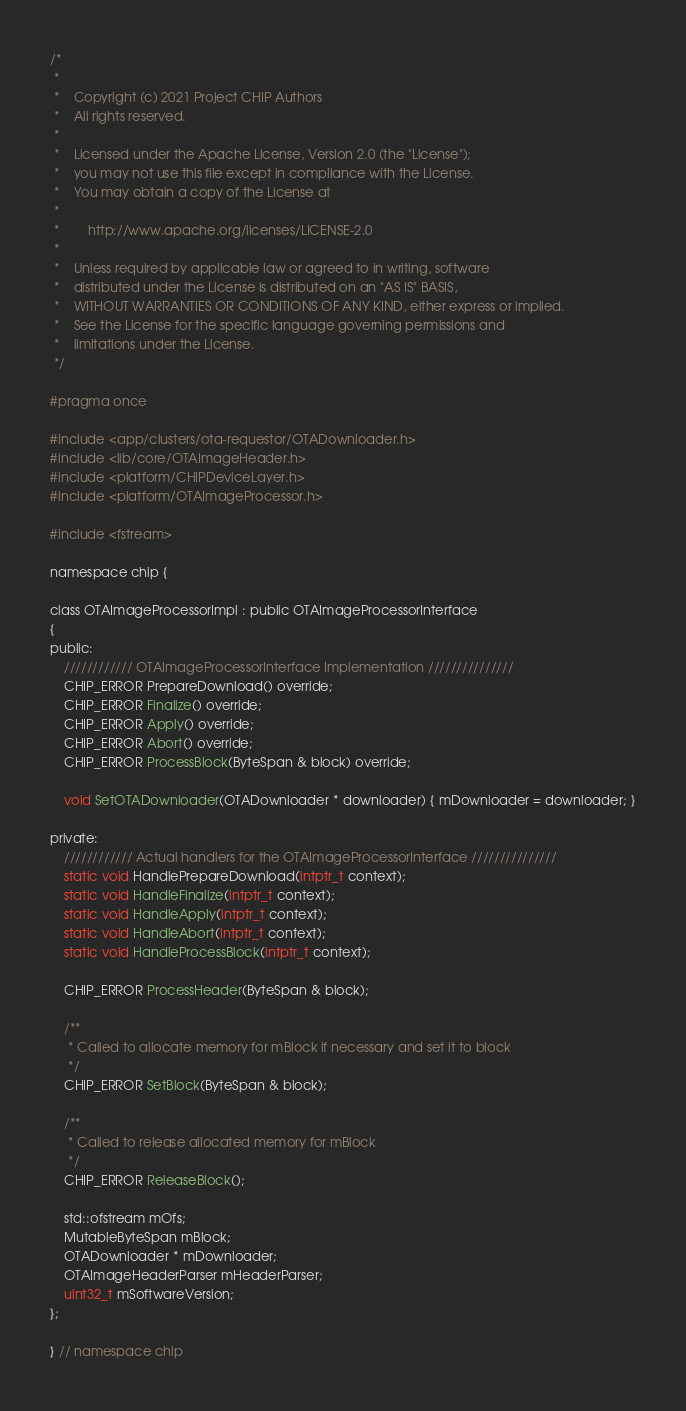<code> <loc_0><loc_0><loc_500><loc_500><_C_>/*
 *
 *    Copyright (c) 2021 Project CHIP Authors
 *    All rights reserved.
 *
 *    Licensed under the Apache License, Version 2.0 (the "License");
 *    you may not use this file except in compliance with the License.
 *    You may obtain a copy of the License at
 *
 *        http://www.apache.org/licenses/LICENSE-2.0
 *
 *    Unless required by applicable law or agreed to in writing, software
 *    distributed under the License is distributed on an "AS IS" BASIS,
 *    WITHOUT WARRANTIES OR CONDITIONS OF ANY KIND, either express or implied.
 *    See the License for the specific language governing permissions and
 *    limitations under the License.
 */

#pragma once

#include <app/clusters/ota-requestor/OTADownloader.h>
#include <lib/core/OTAImageHeader.h>
#include <platform/CHIPDeviceLayer.h>
#include <platform/OTAImageProcessor.h>

#include <fstream>

namespace chip {

class OTAImageProcessorImpl : public OTAImageProcessorInterface
{
public:
    //////////// OTAImageProcessorInterface Implementation ///////////////
    CHIP_ERROR PrepareDownload() override;
    CHIP_ERROR Finalize() override;
    CHIP_ERROR Apply() override;
    CHIP_ERROR Abort() override;
    CHIP_ERROR ProcessBlock(ByteSpan & block) override;

    void SetOTADownloader(OTADownloader * downloader) { mDownloader = downloader; }

private:
    //////////// Actual handlers for the OTAImageProcessorInterface ///////////////
    static void HandlePrepareDownload(intptr_t context);
    static void HandleFinalize(intptr_t context);
    static void HandleApply(intptr_t context);
    static void HandleAbort(intptr_t context);
    static void HandleProcessBlock(intptr_t context);

    CHIP_ERROR ProcessHeader(ByteSpan & block);

    /**
     * Called to allocate memory for mBlock if necessary and set it to block
     */
    CHIP_ERROR SetBlock(ByteSpan & block);

    /**
     * Called to release allocated memory for mBlock
     */
    CHIP_ERROR ReleaseBlock();

    std::ofstream mOfs;
    MutableByteSpan mBlock;
    OTADownloader * mDownloader;
    OTAImageHeaderParser mHeaderParser;
    uint32_t mSoftwareVersion;
};

} // namespace chip
</code> 